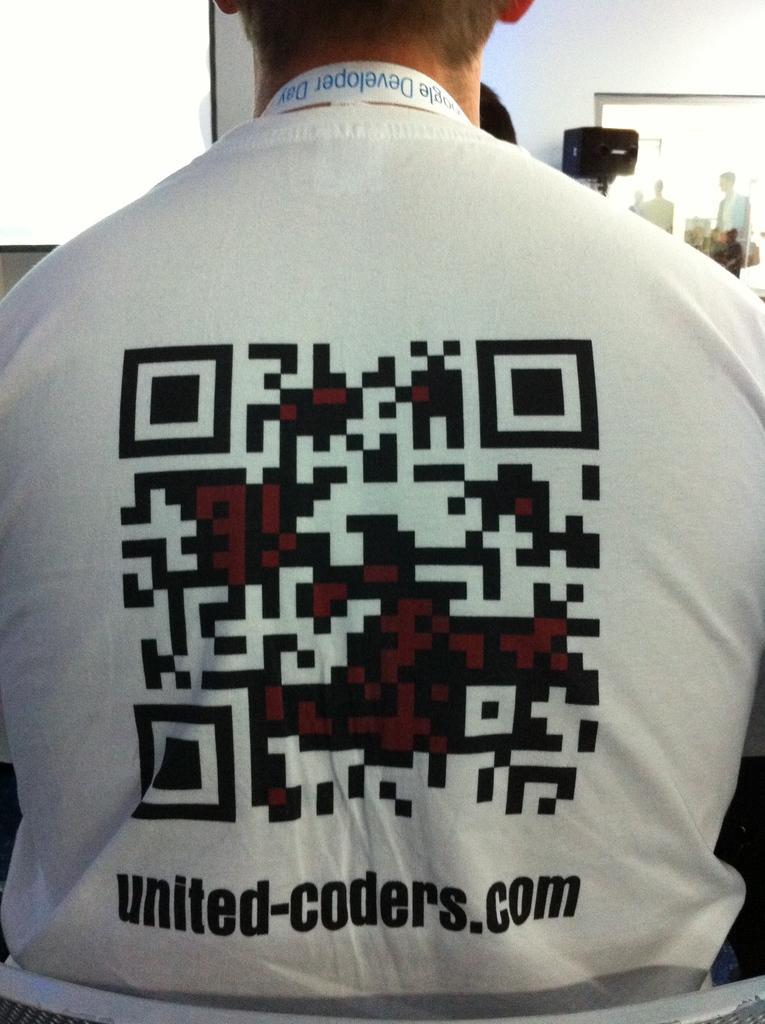How would you summarize this image in a sentence or two? In this image I can see a person is wearing white shirt and something is written on it. In front I can see the white wall. 